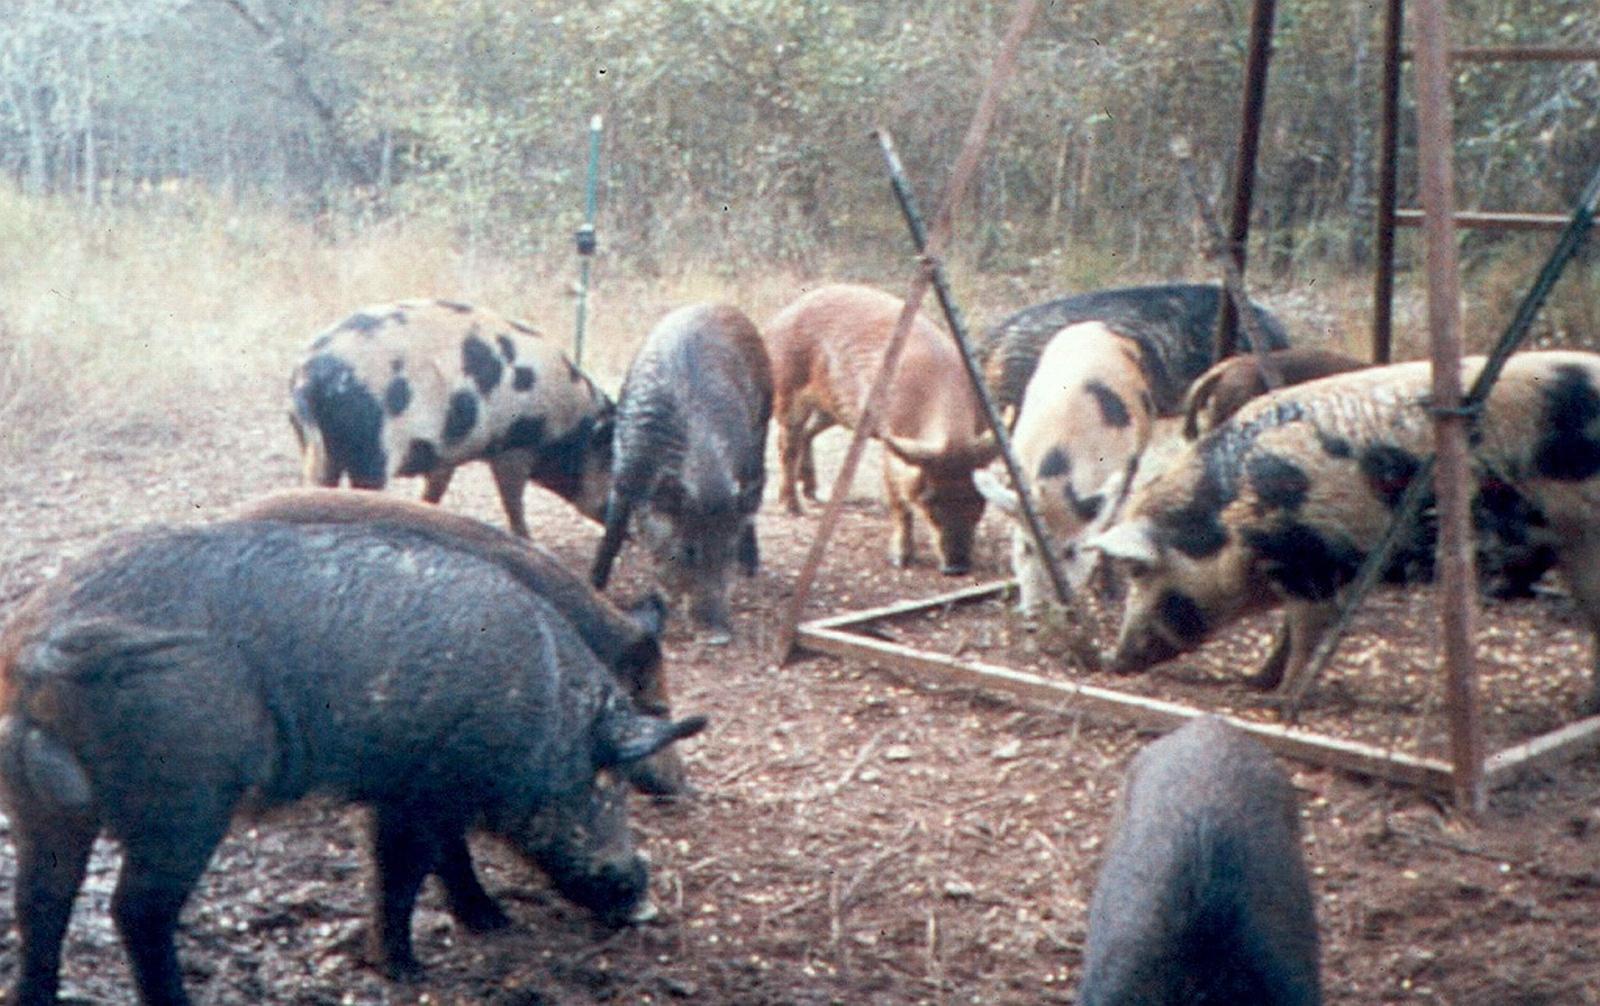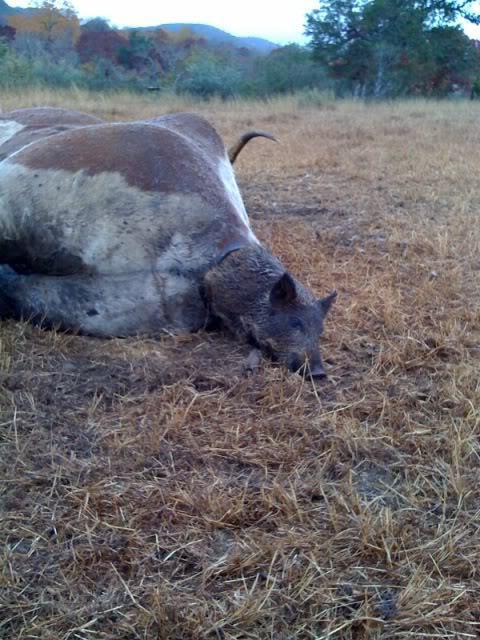The first image is the image on the left, the second image is the image on the right. Considering the images on both sides, is "The left image contains no more than three wild boars." valid? Answer yes or no. No. 